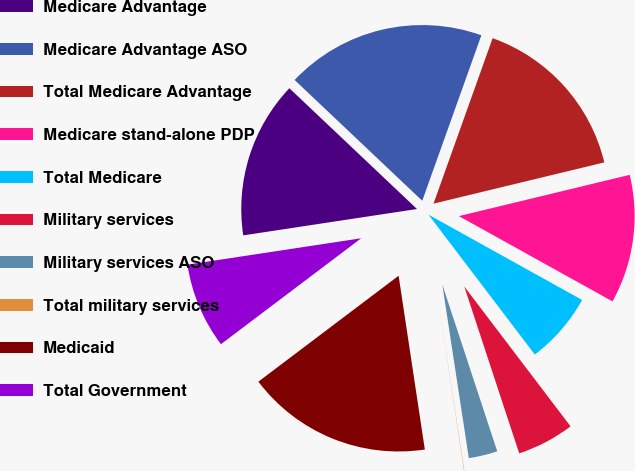<chart> <loc_0><loc_0><loc_500><loc_500><pie_chart><fcel>Medicare Advantage<fcel>Medicare Advantage ASO<fcel>Total Medicare Advantage<fcel>Medicare stand-alone PDP<fcel>Total Medicare<fcel>Military services<fcel>Military services ASO<fcel>Total military services<fcel>Medicaid<fcel>Total Government<nl><fcel>14.46%<fcel>18.4%<fcel>15.77%<fcel>11.84%<fcel>6.59%<fcel>5.28%<fcel>2.65%<fcel>0.03%<fcel>17.09%<fcel>7.9%<nl></chart> 